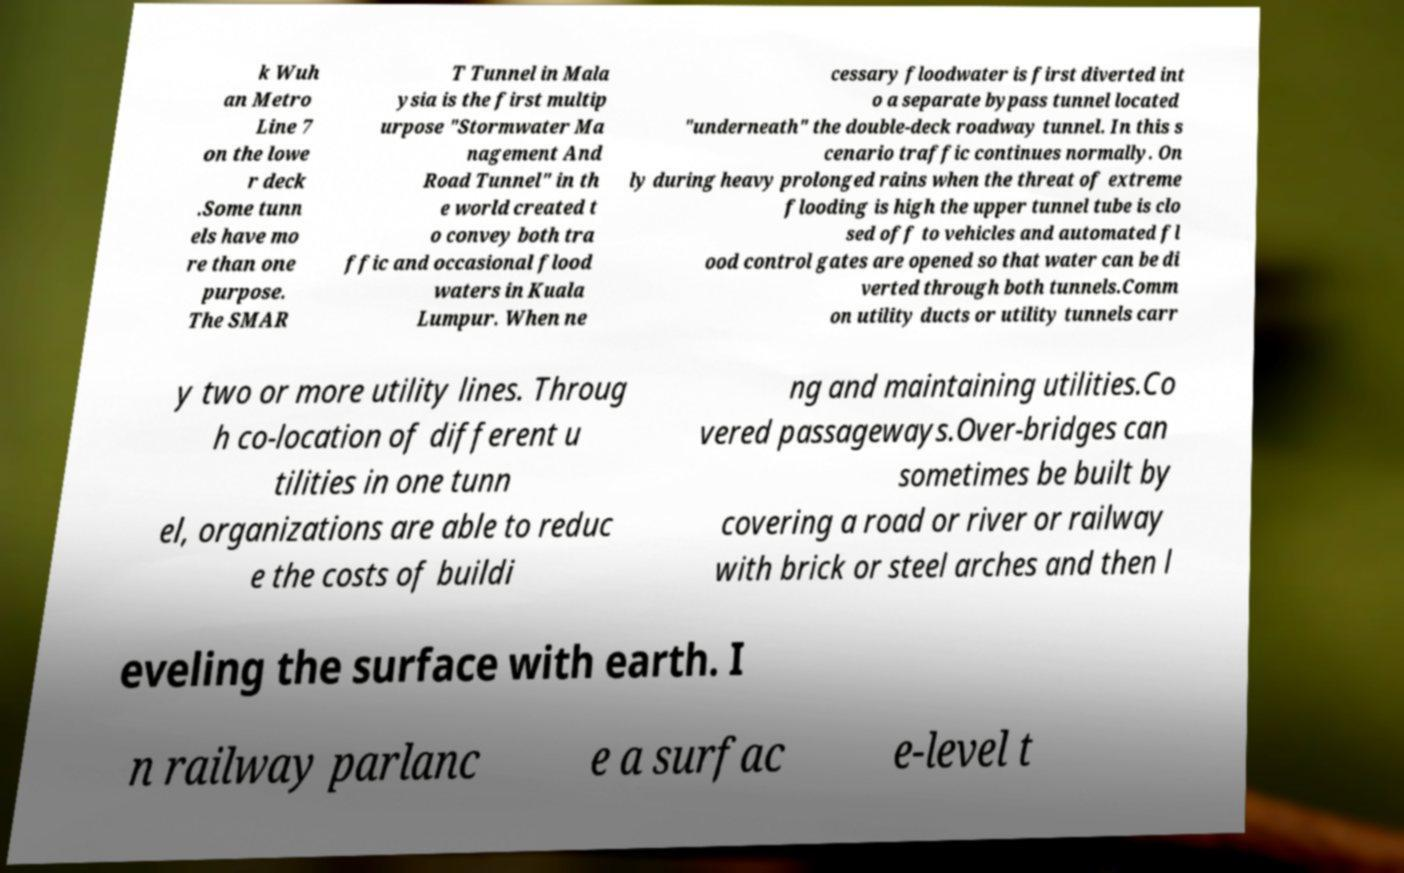For documentation purposes, I need the text within this image transcribed. Could you provide that? k Wuh an Metro Line 7 on the lowe r deck .Some tunn els have mo re than one purpose. The SMAR T Tunnel in Mala ysia is the first multip urpose "Stormwater Ma nagement And Road Tunnel" in th e world created t o convey both tra ffic and occasional flood waters in Kuala Lumpur. When ne cessary floodwater is first diverted int o a separate bypass tunnel located "underneath" the double-deck roadway tunnel. In this s cenario traffic continues normally. On ly during heavy prolonged rains when the threat of extreme flooding is high the upper tunnel tube is clo sed off to vehicles and automated fl ood control gates are opened so that water can be di verted through both tunnels.Comm on utility ducts or utility tunnels carr y two or more utility lines. Throug h co-location of different u tilities in one tunn el, organizations are able to reduc e the costs of buildi ng and maintaining utilities.Co vered passageways.Over-bridges can sometimes be built by covering a road or river or railway with brick or steel arches and then l eveling the surface with earth. I n railway parlanc e a surfac e-level t 